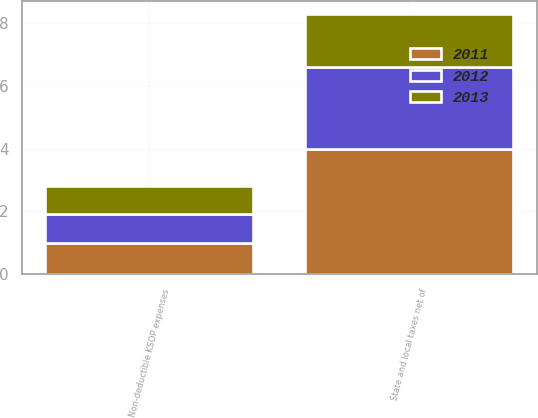Convert chart to OTSL. <chart><loc_0><loc_0><loc_500><loc_500><stacked_bar_chart><ecel><fcel>State and local taxes net of<fcel>Non-deductible KSOP expenses<nl><fcel>2012<fcel>2.6<fcel>0.9<nl><fcel>2013<fcel>1.7<fcel>0.9<nl><fcel>2011<fcel>4<fcel>1<nl></chart> 